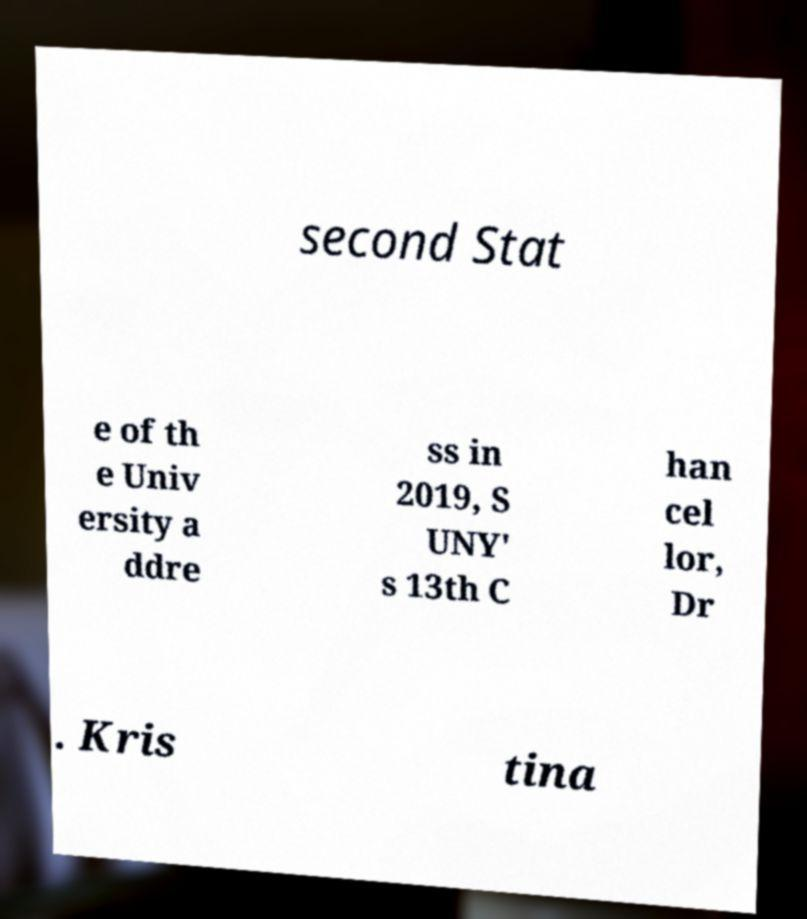Please identify and transcribe the text found in this image. second Stat e of th e Univ ersity a ddre ss in 2019, S UNY' s 13th C han cel lor, Dr . Kris tina 